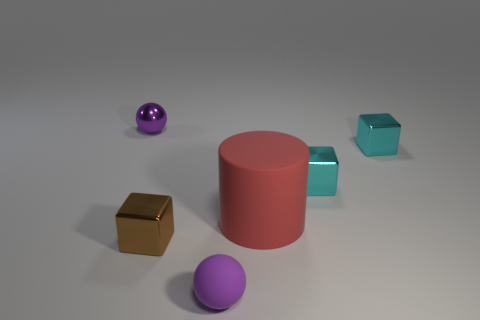Is there a tiny brown cube that is behind the tiny ball behind the purple rubber sphere?
Offer a terse response. No. Is the number of large red things on the right side of the red cylinder less than the number of purple things that are to the left of the tiny purple matte thing?
Offer a terse response. Yes. Are there any other things that have the same size as the cylinder?
Ensure brevity in your answer.  No. What shape is the brown metallic thing?
Make the answer very short. Cube. There is a tiny purple sphere in front of the brown metallic block; what is its material?
Your answer should be very brief. Rubber. What is the size of the matte thing behind the tiny purple object right of the small ball behind the cylinder?
Your answer should be very brief. Large. Is the material of the small sphere behind the brown thing the same as the block that is left of the small purple matte sphere?
Make the answer very short. Yes. What number of other things are there of the same color as the big matte cylinder?
Provide a succinct answer. 0. How many objects are purple objects that are behind the tiny brown object or blocks that are right of the brown shiny block?
Your answer should be compact. 3. There is a purple ball that is right of the small purple sphere that is behind the purple rubber object; how big is it?
Provide a succinct answer. Small. 